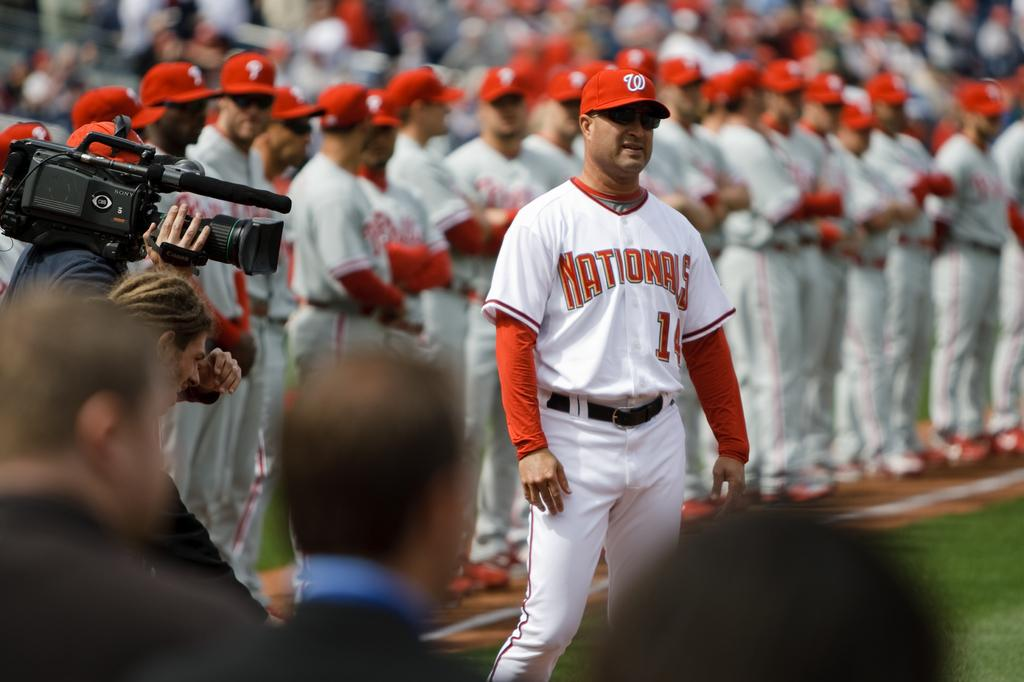Provide a one-sentence caption for the provided image. The Nationals baseball team stand up facing forward on the field. 